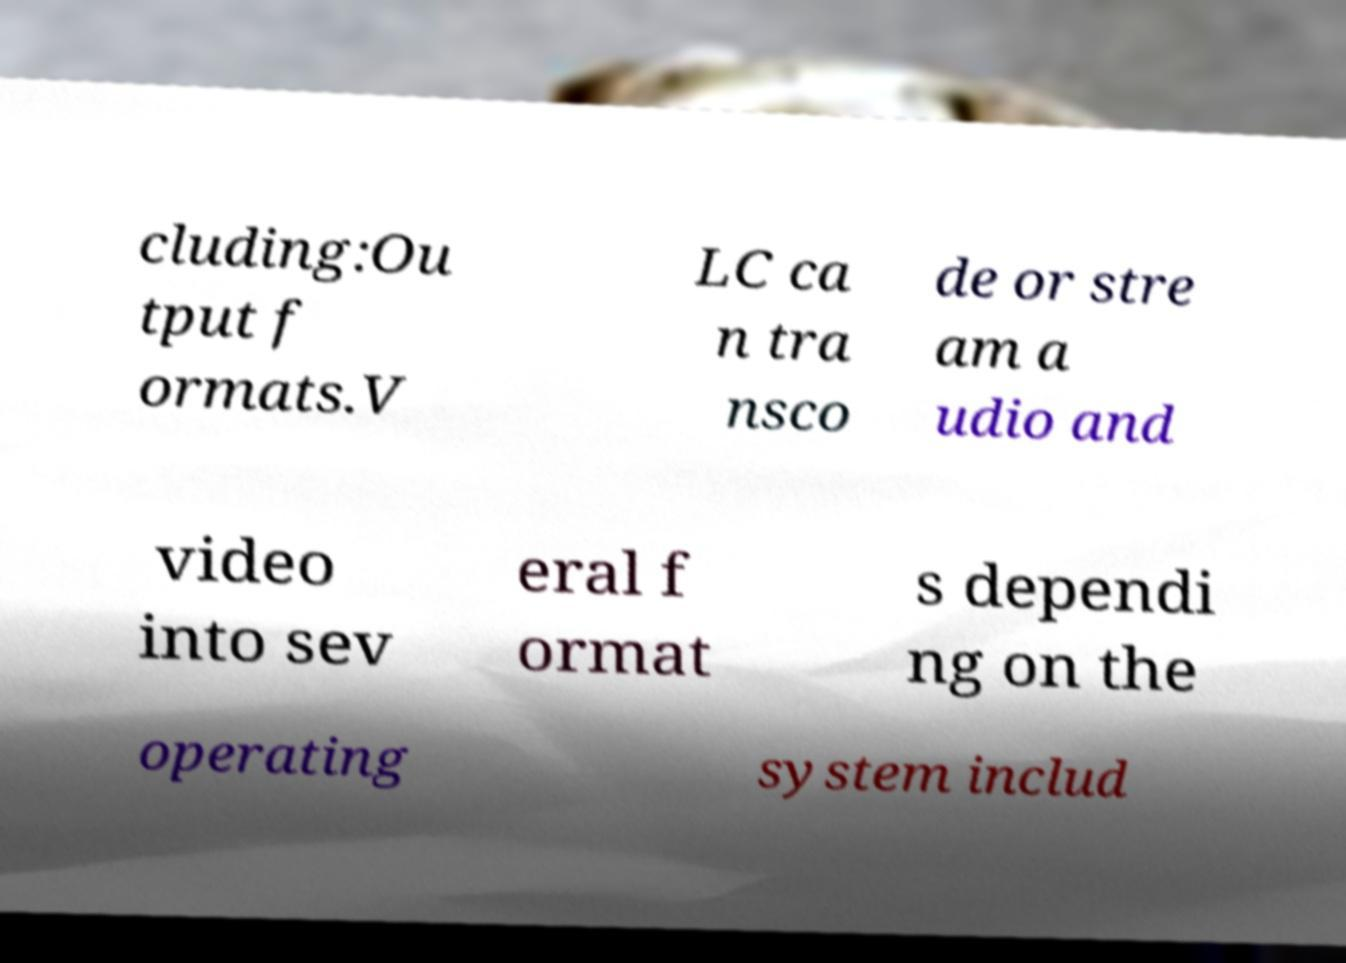Please read and relay the text visible in this image. What does it say? cluding:Ou tput f ormats.V LC ca n tra nsco de or stre am a udio and video into sev eral f ormat s dependi ng on the operating system includ 